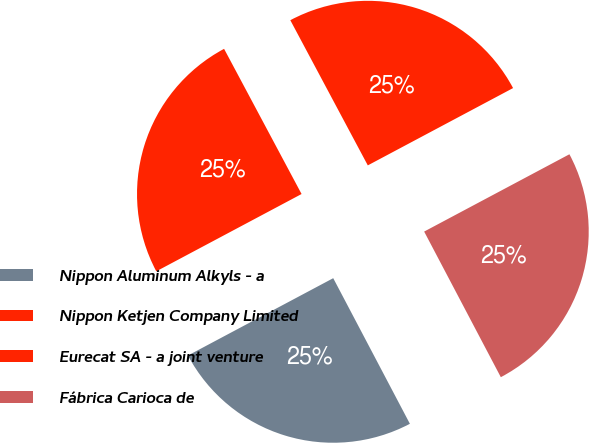Convert chart to OTSL. <chart><loc_0><loc_0><loc_500><loc_500><pie_chart><fcel>Nippon Aluminum Alkyls - a<fcel>Nippon Ketjen Company Limited<fcel>Eurecat SA - a joint venture<fcel>Fábrica Carioca de<nl><fcel>24.93%<fcel>24.98%<fcel>25.02%<fcel>25.07%<nl></chart> 